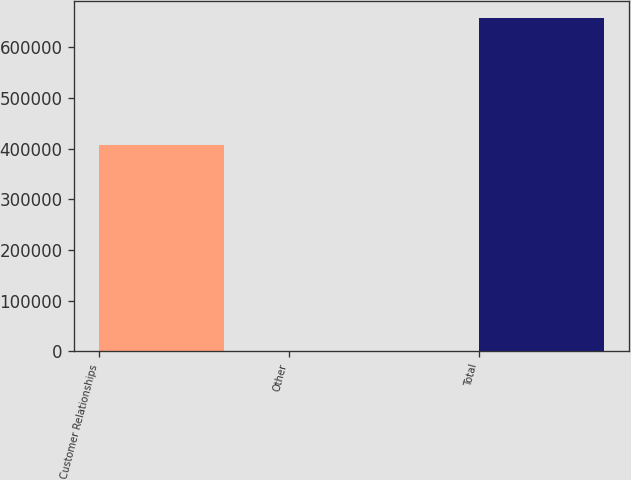Convert chart. <chart><loc_0><loc_0><loc_500><loc_500><bar_chart><fcel>Customer Relationships<fcel>Other<fcel>Total<nl><fcel>406386<fcel>1227<fcel>657601<nl></chart> 